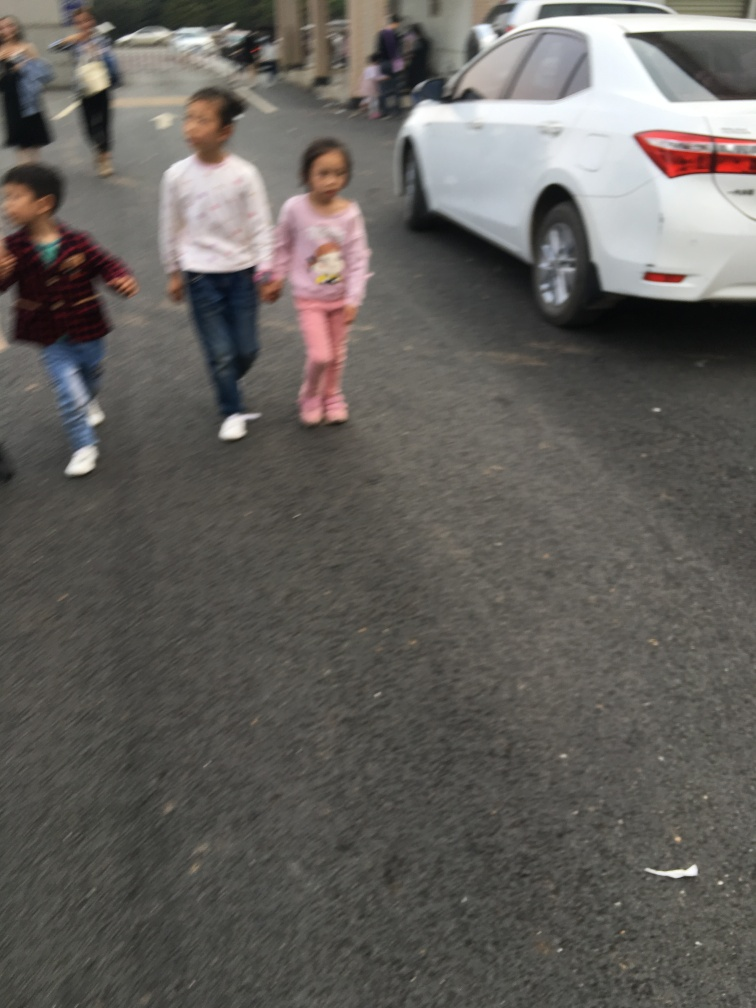What can we infer about the time of day or weather in this image? The lighting in the image appears to be natural and not too harsh, which might indicate it was taken during the early morning or late afternoon. The overcast sky suggests it could be a cloudy day. There are no strong shadows, and the attire of the people in the background hints at mild weather, neither too hot nor too cold. 